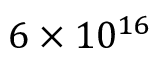<formula> <loc_0><loc_0><loc_500><loc_500>6 \times 1 0 ^ { 1 6 }</formula> 